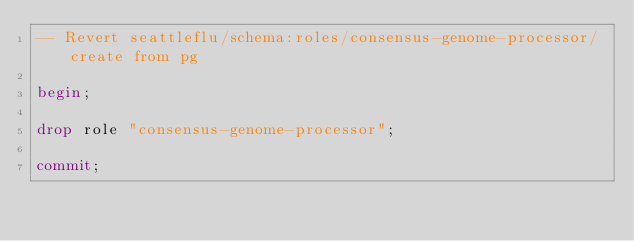Convert code to text. <code><loc_0><loc_0><loc_500><loc_500><_SQL_>-- Revert seattleflu/schema:roles/consensus-genome-processor/create from pg

begin;

drop role "consensus-genome-processor";

commit;
</code> 